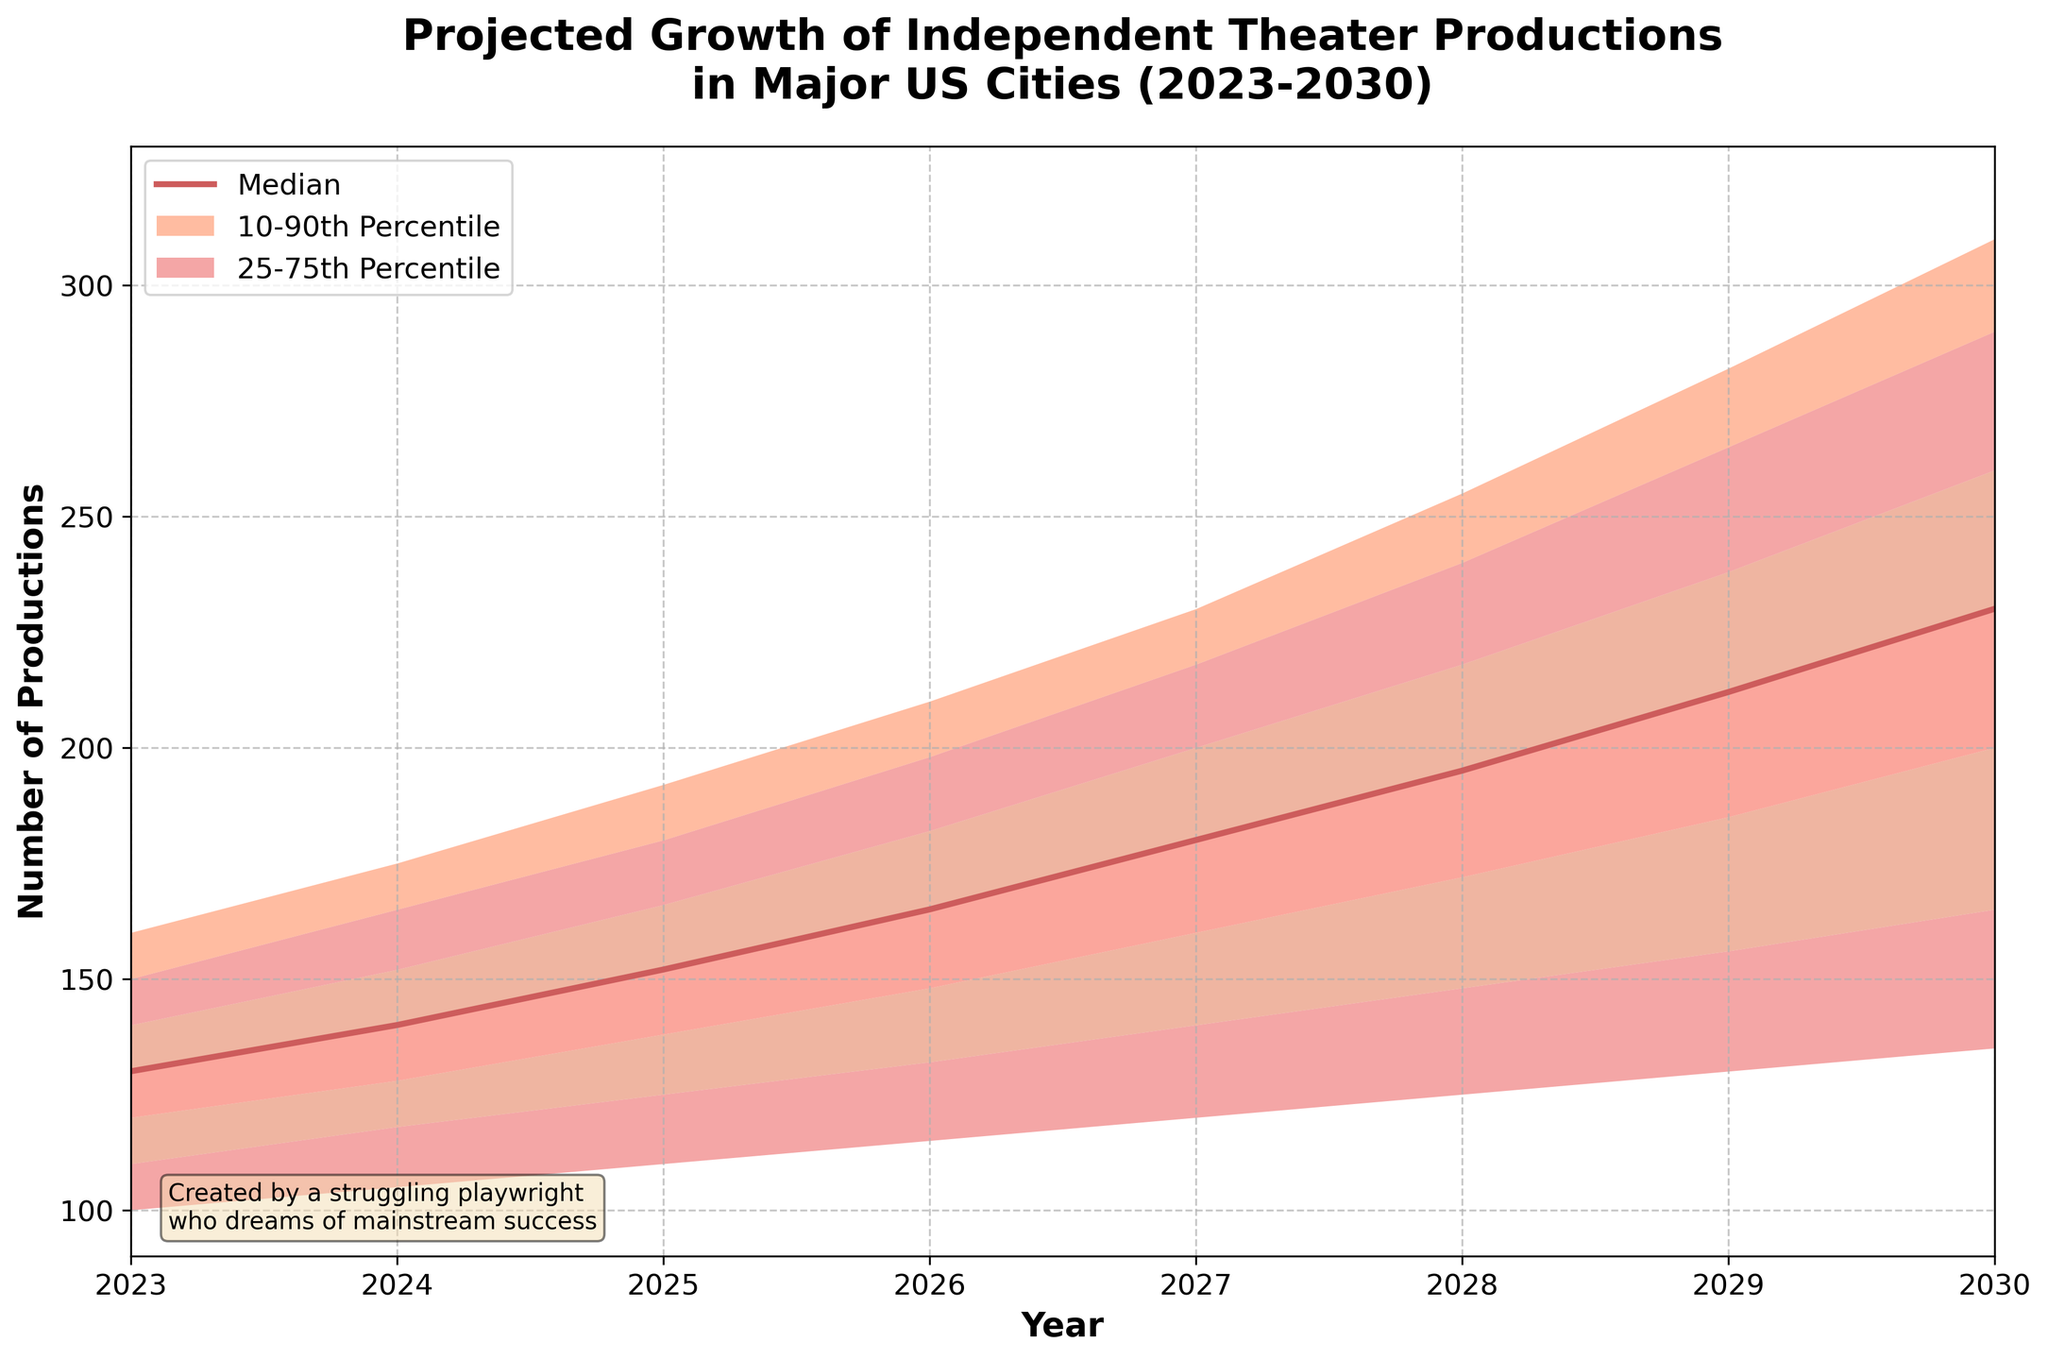What is the title of the chart? The title is located at the top of the chart. It reads, "Projected Growth of Independent Theater Productions in Major US Cities (2023-2030)."
Answer: Projected Growth of Independent Theater Productions in Major US Cities (2023-2030) What are the labels on the x-axis and y-axis? The x-axis label is below the axis, and it states "Year." The y-axis label is to the left of the axis, and it states "Number of Productions."
Answer: Year, Number of Productions Which percentile has the darkest shaded area in the chart? The darkest shaded area in the chart represents the 25th to 75th percentiles.
Answer: 25th to 75th percentiles What is the median projected number of productions in 2027? Locate the median line, which is colored in a darker shade. The median value for 2027 is 180.
Answer: 180 How many years of data are presented in the chart? Identify the range on the x-axis, which starts from 2023 and ends at 2030. Calculating the number of years within this range gives us 8 years.
Answer: 8 What is the projected number of productions at the 10th percentile in 2024? Find the 10th percentile shaded area and locate its corresponding value in 2024, which is 118.
Answer: 118 By how much does the median projected number of productions increase from 2023 to 2030? The median value in 2023 is 130, and in 2030, it is 230. Subtract 130 from 230 to find the increase, which is 100.
Answer: 100 How does the range between the high and low values change from 2023 to 2030? The high value in 2023 is 160 and the low value is 100; the range is 60. In 2030, the high value is 310 and the low value is 135, giving a range of 175. The difference in range from 2032 to 2030 is 175 minus 60, which is 115.
Answer: The range increases by 115 What projected percentile range does the lightest shaded area represent? The lightest shaded area represents the range between the low and high percentiles.
Answer: Low to High percentile What is the projected number of productions at the 75th percentile in 2029, and how does it compare to the median in 2025? The 75th percentile value in 2029 is 238. The median value in 2025 is 152. The difference between these values is 238 - 152 = 86.
Answer: 238; 86 